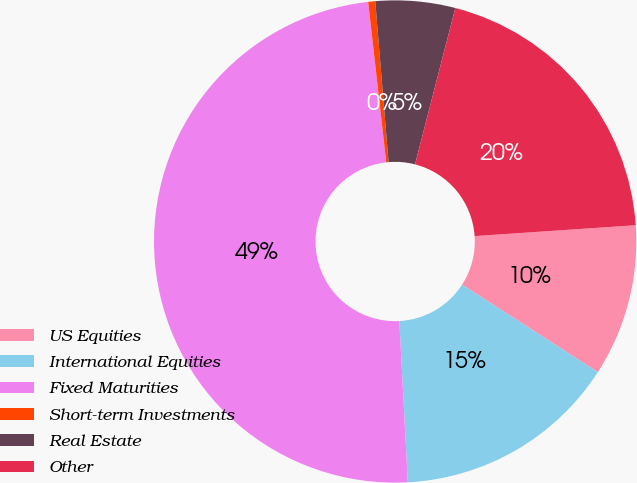Convert chart to OTSL. <chart><loc_0><loc_0><loc_500><loc_500><pie_chart><fcel>US Equities<fcel>International Equities<fcel>Fixed Maturities<fcel>Short-term Investments<fcel>Real Estate<fcel>Other<nl><fcel>10.19%<fcel>15.05%<fcel>49.05%<fcel>0.47%<fcel>5.33%<fcel>19.91%<nl></chart> 